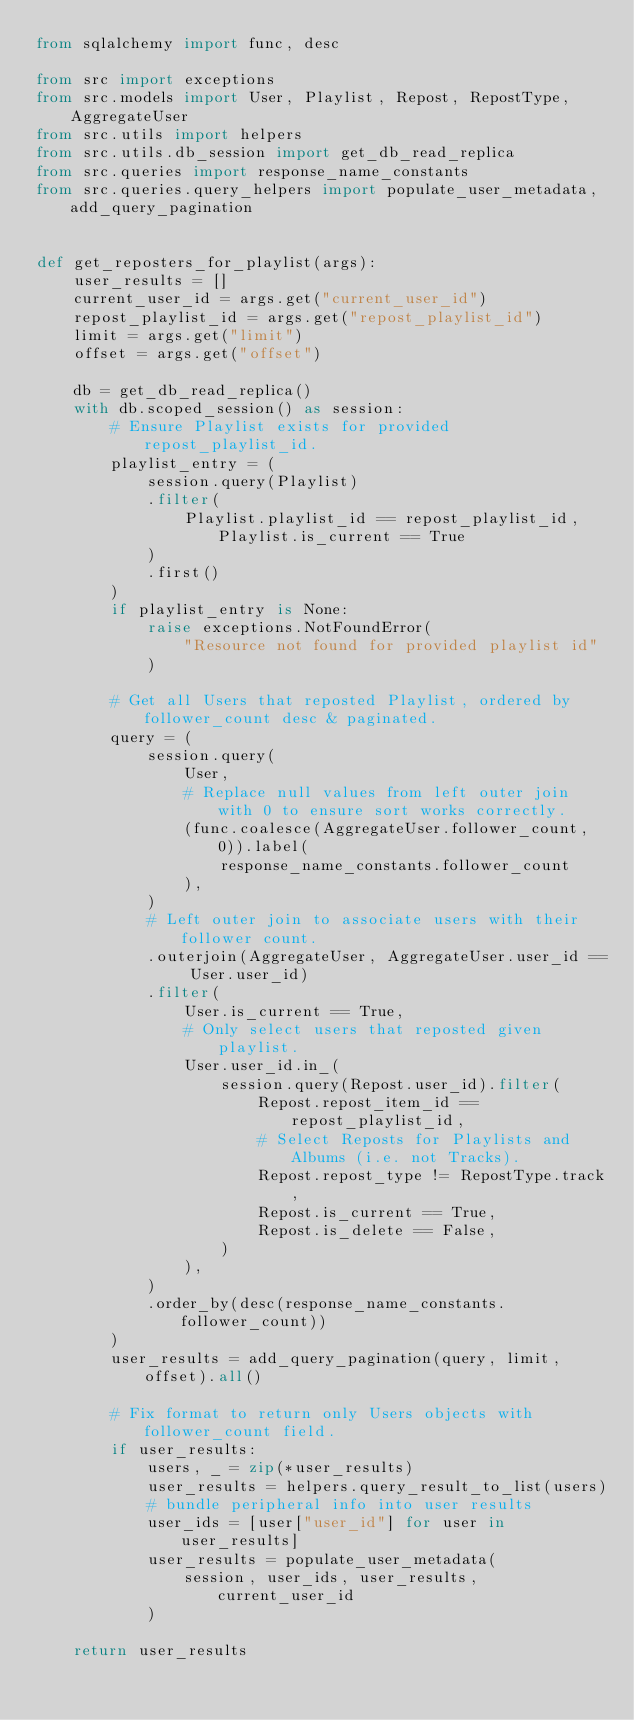<code> <loc_0><loc_0><loc_500><loc_500><_Python_>from sqlalchemy import func, desc

from src import exceptions
from src.models import User, Playlist, Repost, RepostType, AggregateUser
from src.utils import helpers
from src.utils.db_session import get_db_read_replica
from src.queries import response_name_constants
from src.queries.query_helpers import populate_user_metadata, add_query_pagination


def get_reposters_for_playlist(args):
    user_results = []
    current_user_id = args.get("current_user_id")
    repost_playlist_id = args.get("repost_playlist_id")
    limit = args.get("limit")
    offset = args.get("offset")

    db = get_db_read_replica()
    with db.scoped_session() as session:
        # Ensure Playlist exists for provided repost_playlist_id.
        playlist_entry = (
            session.query(Playlist)
            .filter(
                Playlist.playlist_id == repost_playlist_id, Playlist.is_current == True
            )
            .first()
        )
        if playlist_entry is None:
            raise exceptions.NotFoundError(
                "Resource not found for provided playlist id"
            )

        # Get all Users that reposted Playlist, ordered by follower_count desc & paginated.
        query = (
            session.query(
                User,
                # Replace null values from left outer join with 0 to ensure sort works correctly.
                (func.coalesce(AggregateUser.follower_count, 0)).label(
                    response_name_constants.follower_count
                ),
            )
            # Left outer join to associate users with their follower count.
            .outerjoin(AggregateUser, AggregateUser.user_id == User.user_id)
            .filter(
                User.is_current == True,
                # Only select users that reposted given playlist.
                User.user_id.in_(
                    session.query(Repost.user_id).filter(
                        Repost.repost_item_id == repost_playlist_id,
                        # Select Reposts for Playlists and Albums (i.e. not Tracks).
                        Repost.repost_type != RepostType.track,
                        Repost.is_current == True,
                        Repost.is_delete == False,
                    )
                ),
            )
            .order_by(desc(response_name_constants.follower_count))
        )
        user_results = add_query_pagination(query, limit, offset).all()

        # Fix format to return only Users objects with follower_count field.
        if user_results:
            users, _ = zip(*user_results)
            user_results = helpers.query_result_to_list(users)
            # bundle peripheral info into user results
            user_ids = [user["user_id"] for user in user_results]
            user_results = populate_user_metadata(
                session, user_ids, user_results, current_user_id
            )

    return user_results
</code> 